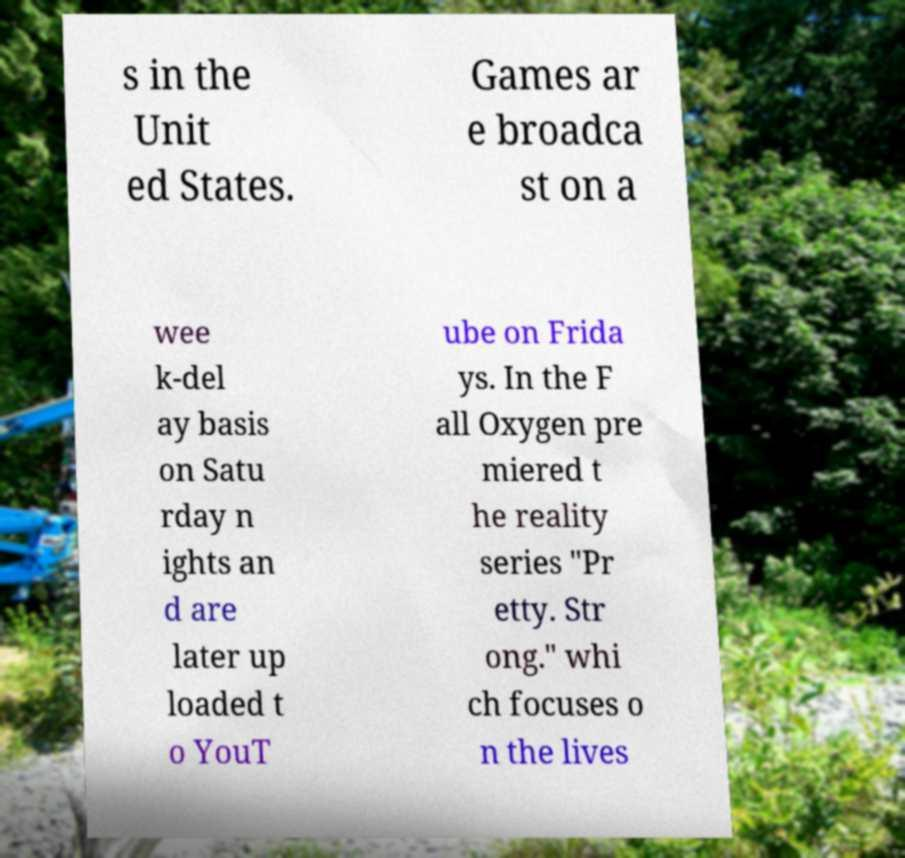I need the written content from this picture converted into text. Can you do that? s in the Unit ed States. Games ar e broadca st on a wee k-del ay basis on Satu rday n ights an d are later up loaded t o YouT ube on Frida ys. In the F all Oxygen pre miered t he reality series "Pr etty. Str ong." whi ch focuses o n the lives 